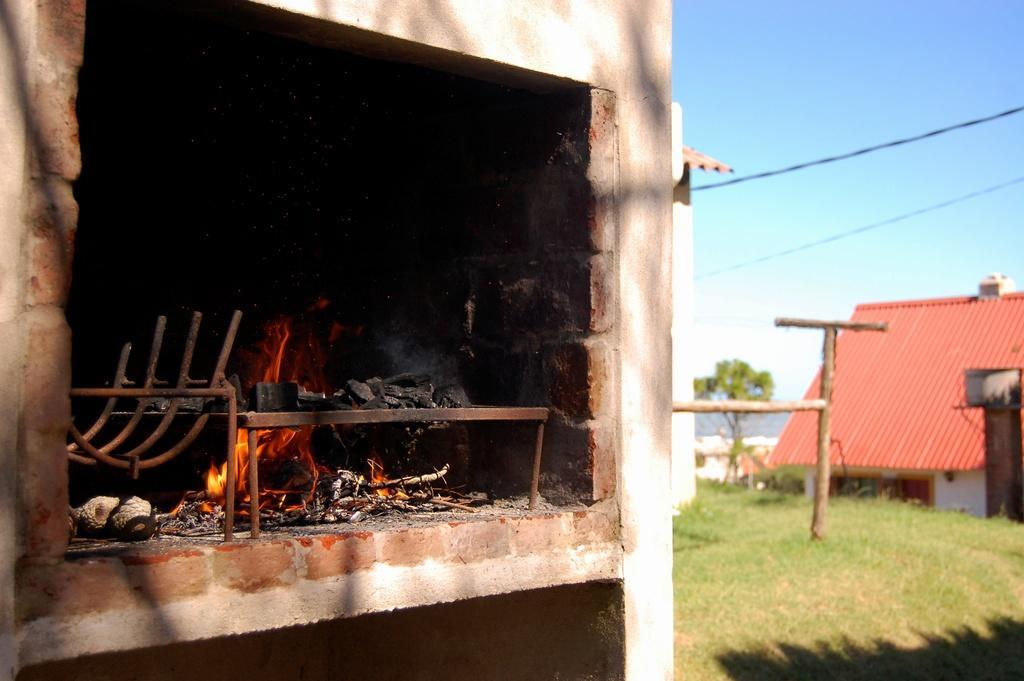Describe this image in one or two sentences. In the foreground of this image, there is a hearth on the left. On the right, there are two houses, wooden pole structure, grass, a tree, a chimney like an object, cables and the sky. 